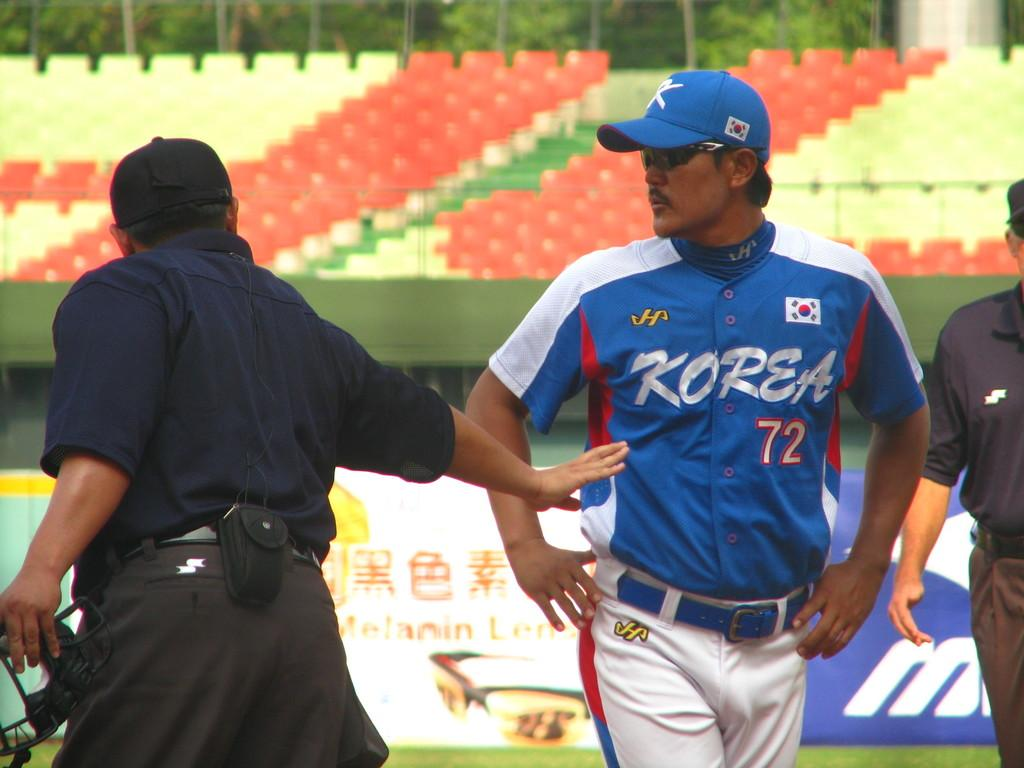<image>
Render a clear and concise summary of the photo. Baseball player for Korea walking off the field 